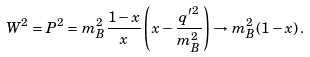Convert formula to latex. <formula><loc_0><loc_0><loc_500><loc_500>W ^ { 2 } = P ^ { 2 } = m _ { B } ^ { 2 } \frac { 1 - x } { x } \left ( x - \frac { { q ^ { \prime } } ^ { 2 } } { m _ { B } ^ { 2 } } \right ) \to m _ { B } ^ { 2 } ( 1 - x ) \, .</formula> 